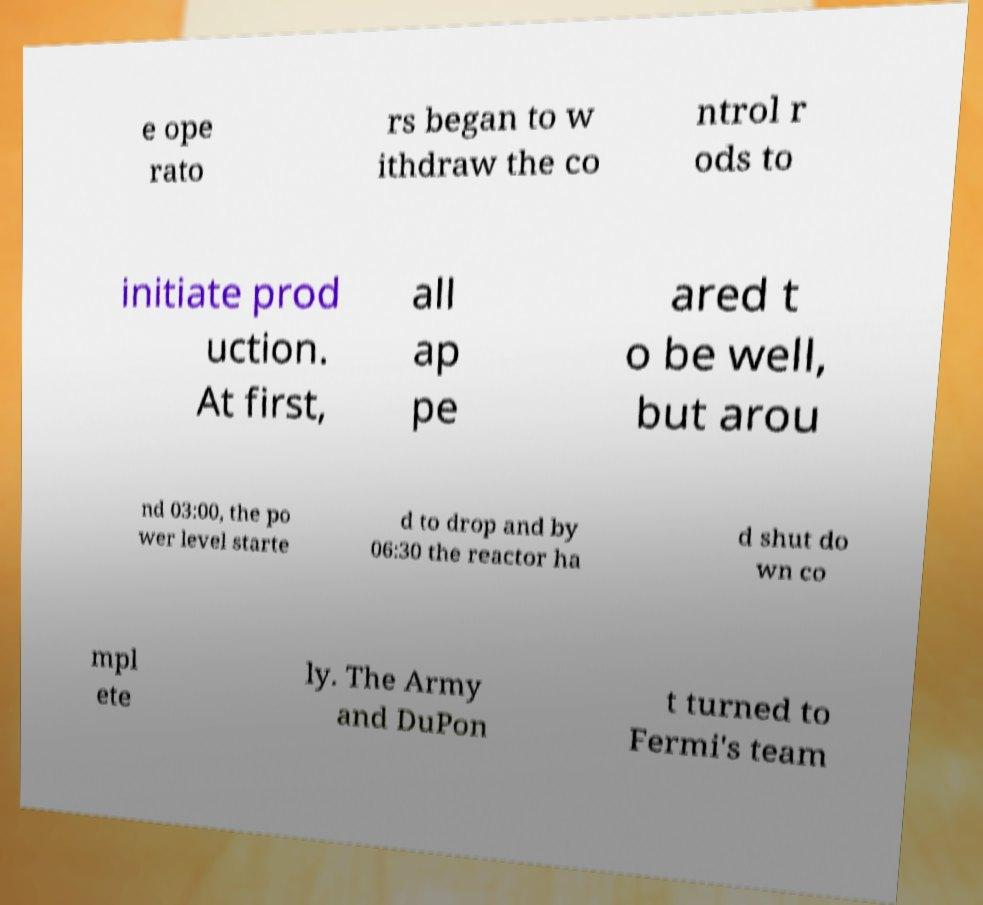Please identify and transcribe the text found in this image. e ope rato rs began to w ithdraw the co ntrol r ods to initiate prod uction. At first, all ap pe ared t o be well, but arou nd 03:00, the po wer level starte d to drop and by 06:30 the reactor ha d shut do wn co mpl ete ly. The Army and DuPon t turned to Fermi's team 